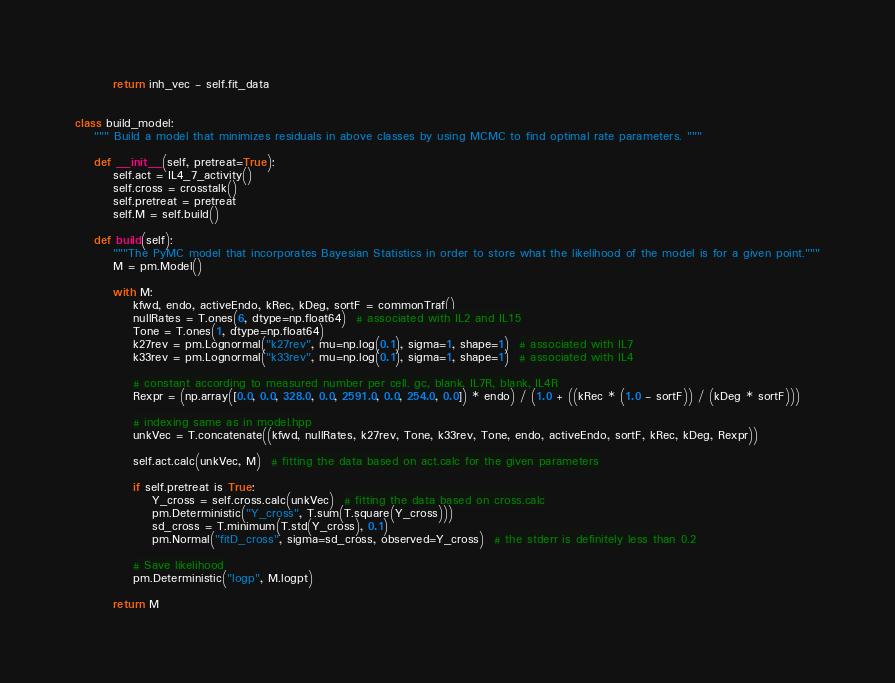Convert code to text. <code><loc_0><loc_0><loc_500><loc_500><_Python_>
        return inh_vec - self.fit_data


class build_model:
    """ Build a model that minimizes residuals in above classes by using MCMC to find optimal rate parameters. """

    def __init__(self, pretreat=True):
        self.act = IL4_7_activity()
        self.cross = crosstalk()
        self.pretreat = pretreat
        self.M = self.build()

    def build(self):
        """The PyMC model that incorporates Bayesian Statistics in order to store what the likelihood of the model is for a given point."""
        M = pm.Model()

        with M:
            kfwd, endo, activeEndo, kRec, kDeg, sortF = commonTraf()
            nullRates = T.ones(6, dtype=np.float64)  # associated with IL2 and IL15
            Tone = T.ones(1, dtype=np.float64)
            k27rev = pm.Lognormal("k27rev", mu=np.log(0.1), sigma=1, shape=1)  # associated with IL7
            k33rev = pm.Lognormal("k33rev", mu=np.log(0.1), sigma=1, shape=1)  # associated with IL4

            # constant according to measured number per cell. gc, blank, IL7R, blank, IL4R
            Rexpr = (np.array([0.0, 0.0, 328.0, 0.0, 2591.0, 0.0, 254.0, 0.0]) * endo) / (1.0 + ((kRec * (1.0 - sortF)) / (kDeg * sortF)))

            # indexing same as in model.hpp
            unkVec = T.concatenate((kfwd, nullRates, k27rev, Tone, k33rev, Tone, endo, activeEndo, sortF, kRec, kDeg, Rexpr))

            self.act.calc(unkVec, M)  # fitting the data based on act.calc for the given parameters

            if self.pretreat is True:
                Y_cross = self.cross.calc(unkVec)  # fitting the data based on cross.calc
                pm.Deterministic("Y_cross", T.sum(T.square(Y_cross)))
                sd_cross = T.minimum(T.std(Y_cross), 0.1)
                pm.Normal("fitD_cross", sigma=sd_cross, observed=Y_cross)  # the stderr is definitely less than 0.2

            # Save likelihood
            pm.Deterministic("logp", M.logpt)

        return M
</code> 